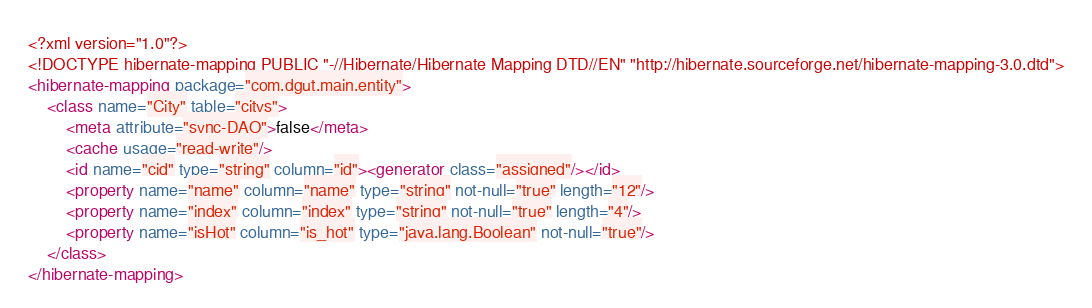Convert code to text. <code><loc_0><loc_0><loc_500><loc_500><_XML_><?xml version="1.0"?>
<!DOCTYPE hibernate-mapping PUBLIC "-//Hibernate/Hibernate Mapping DTD//EN" "http://hibernate.sourceforge.net/hibernate-mapping-3.0.dtd">
<hibernate-mapping package="com.dgut.main.entity">
	<class name="City" table="citys">
		<meta attribute="sync-DAO">false</meta>
		<cache usage="read-write"/>
		<id name="cid" type="string" column="id"><generator class="assigned"/></id>
		<property name="name" column="name" type="string" not-null="true" length="12"/>
		<property name="index" column="index" type="string" not-null="true" length="4"/>
		<property name="isHot" column="is_hot" type="java.lang.Boolean" not-null="true"/>
	</class>
</hibernate-mapping></code> 